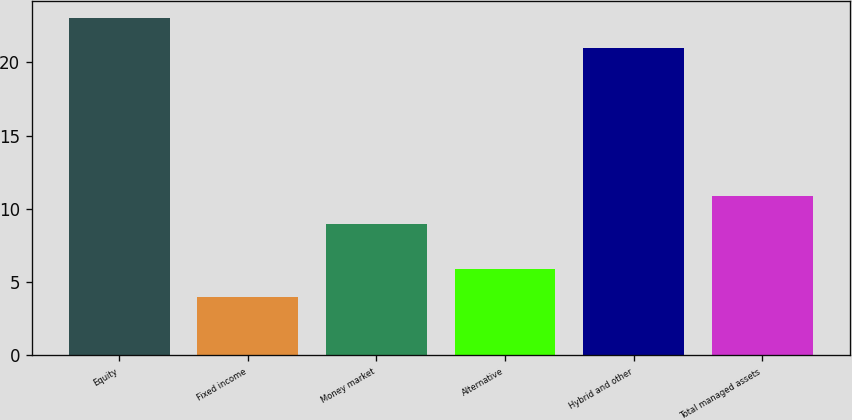Convert chart. <chart><loc_0><loc_0><loc_500><loc_500><bar_chart><fcel>Equity<fcel>Fixed income<fcel>Money market<fcel>Alternative<fcel>Hybrid and other<fcel>Total managed assets<nl><fcel>23<fcel>4<fcel>9<fcel>5.9<fcel>21<fcel>10.9<nl></chart> 